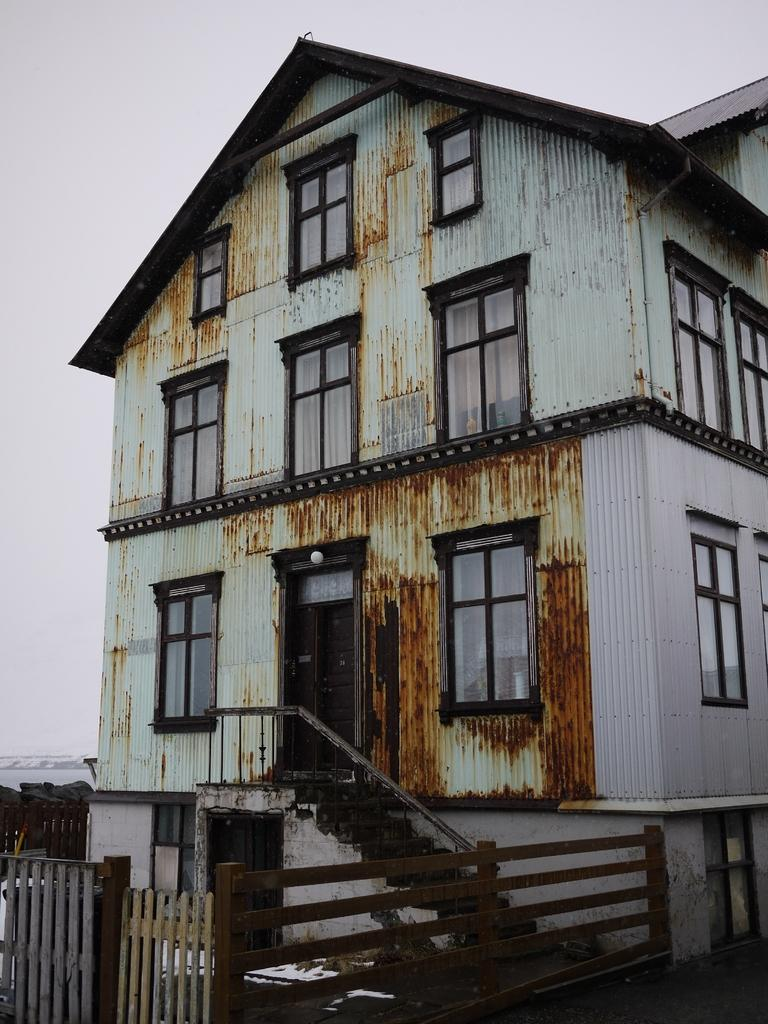What type of structure is present in the image? There is a building in the image. What features can be seen on the building? The building has doors and windows. Is there any source of light visible in the building? Yes, there is a light in the building. What architectural elements are present in front of the building? There are stairs and a wooden fence with a gate in front of the building. What can be seen in the background of the image? The sky is visible in the background of the image. What type of wrist injury can be seen on the person in the image? There is no person present in the image, and therefore no wrist injury can be observed. What type of blade is being used to crush the building in the image? There is no blade or crushing action present in the image; the building is standing intact. 